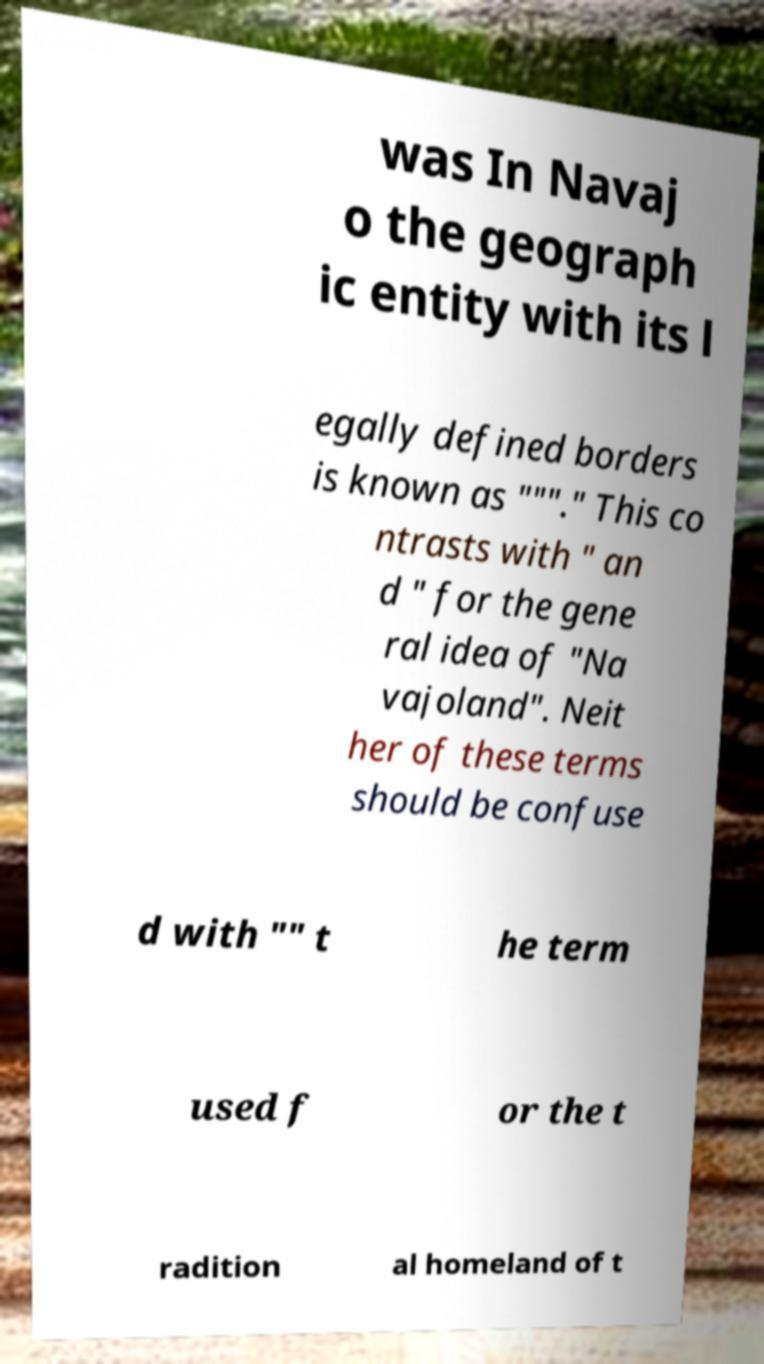For documentation purposes, I need the text within this image transcribed. Could you provide that? was In Navaj o the geograph ic entity with its l egally defined borders is known as """." This co ntrasts with " an d " for the gene ral idea of "Na vajoland". Neit her of these terms should be confuse d with "" t he term used f or the t radition al homeland of t 